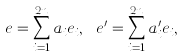Convert formula to latex. <formula><loc_0><loc_0><loc_500><loc_500>e = \sum _ { i = 1 } ^ { 2 n } a _ { i } e _ { i } , \ e ^ { \prime } = \sum _ { i = 1 } ^ { 2 n } a ^ { \prime } _ { i } e _ { i } ,</formula> 